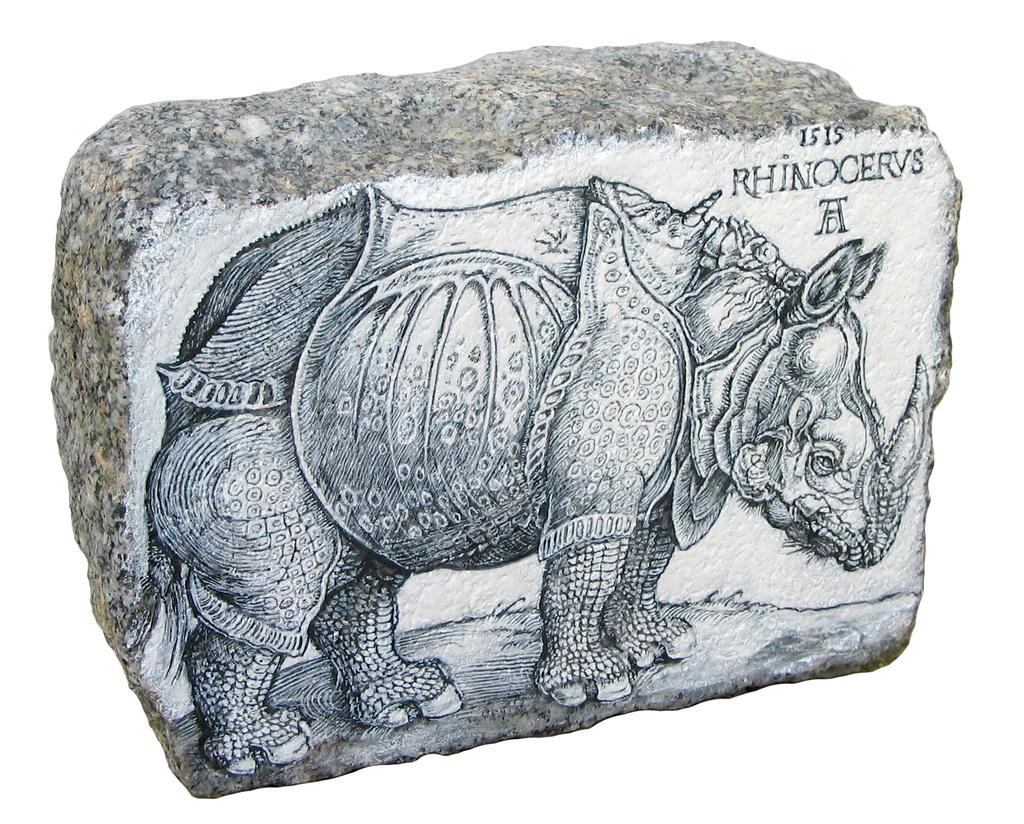What is the main subject of the image? The main subject of the image is a rock. What is unique about the rock? The rock has a painting of an animal on it. Are there any words or letters on the rock? Yes, there is text on the rock. What is the color of the background in the image? The background of the image is white. How many rings can be seen on the tongue of the animal painted on the rock? There is no tongue or rings visible on the animal painted on the rock in the image. 